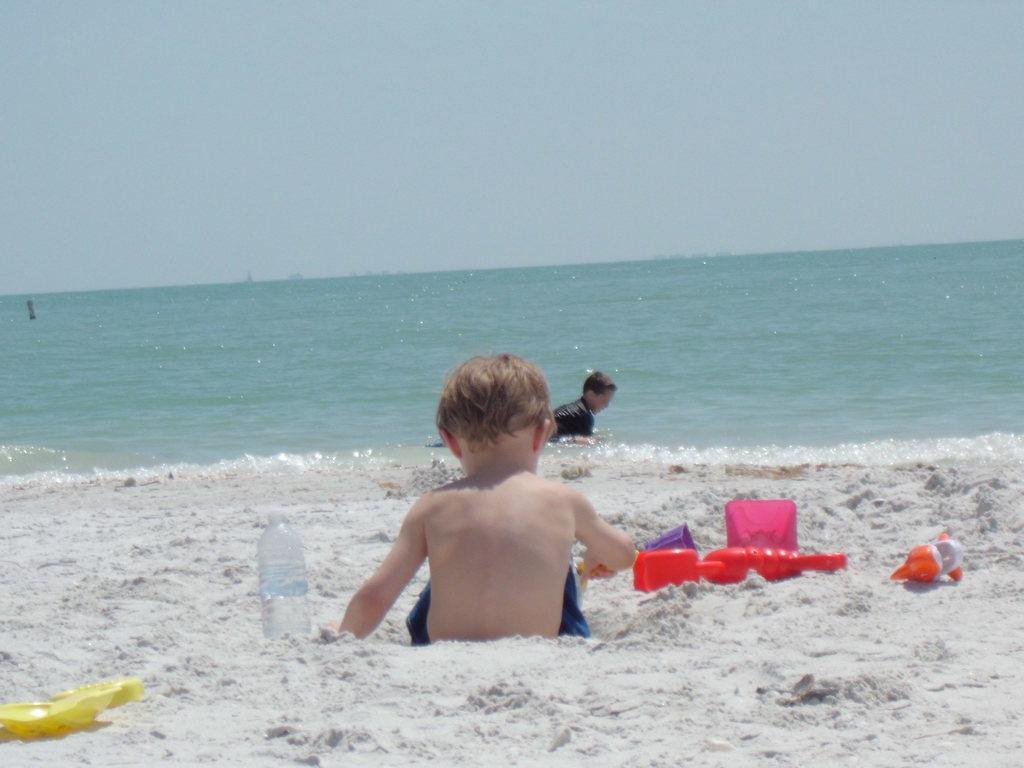How would you summarize this image in a sentence or two? In this picture we can see two kids, a kid in the front is sitting, we can see a bottle and some toys in the front, in the background there is water, we can see the sky at the top of the picture. 